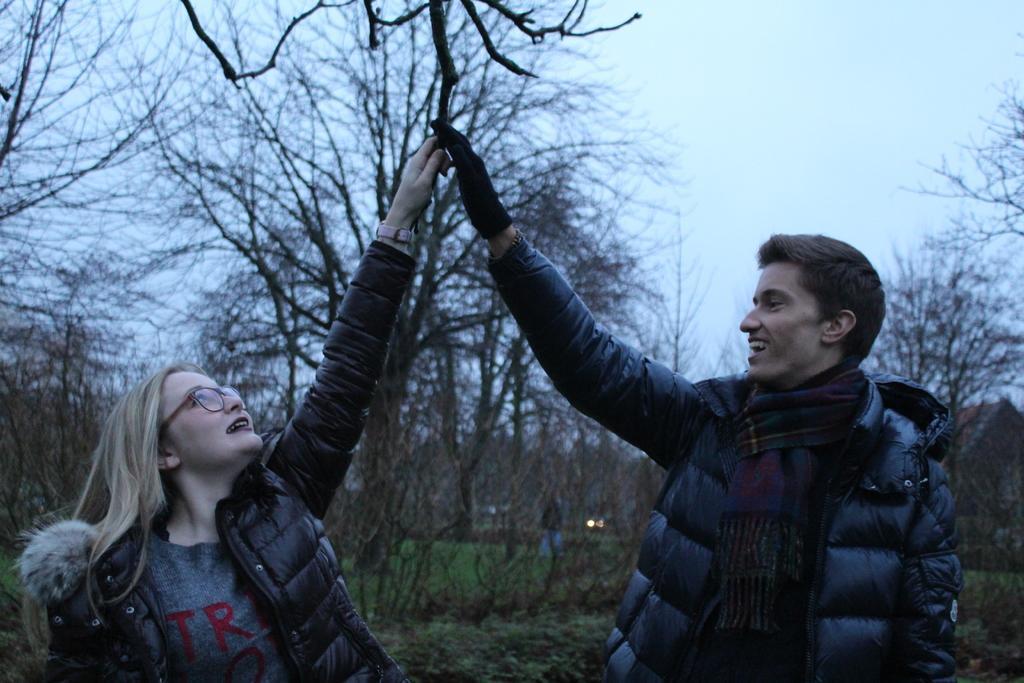Describe this image in one or two sentences. In this image we can see two persons standing, there are some trees, grass and a house, in the background we can see the sky. 